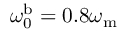<formula> <loc_0><loc_0><loc_500><loc_500>\omega _ { 0 } ^ { b } = 0 . 8 \omega _ { m }</formula> 